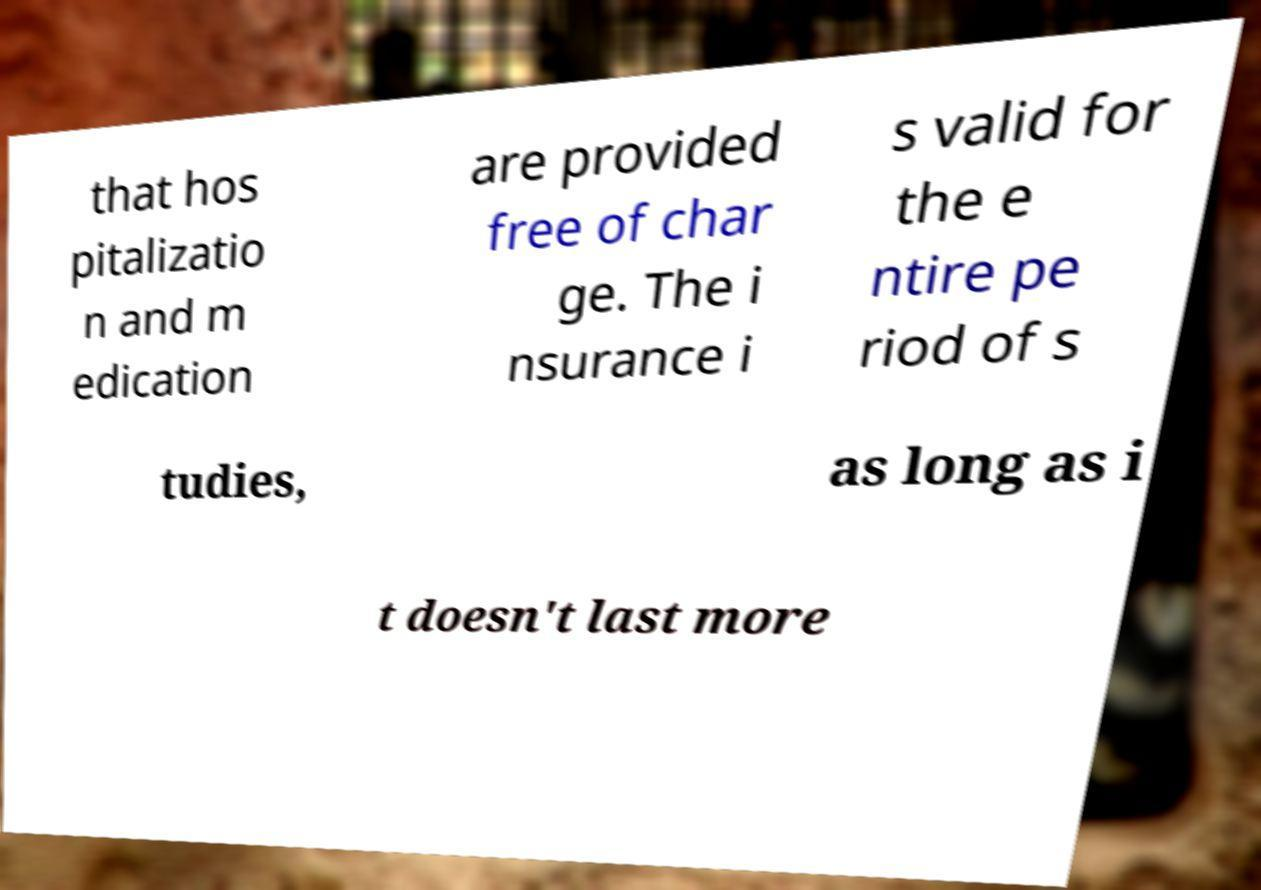Could you assist in decoding the text presented in this image and type it out clearly? that hos pitalizatio n and m edication are provided free of char ge. The i nsurance i s valid for the e ntire pe riod of s tudies, as long as i t doesn't last more 